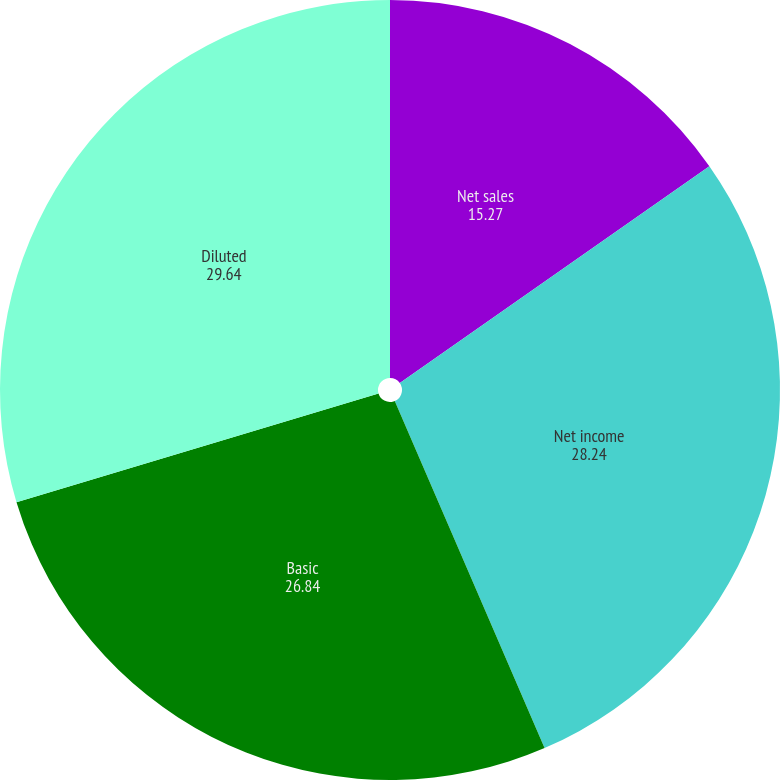<chart> <loc_0><loc_0><loc_500><loc_500><pie_chart><fcel>Net sales<fcel>Net income<fcel>Basic<fcel>Diluted<nl><fcel>15.27%<fcel>28.24%<fcel>26.84%<fcel>29.64%<nl></chart> 